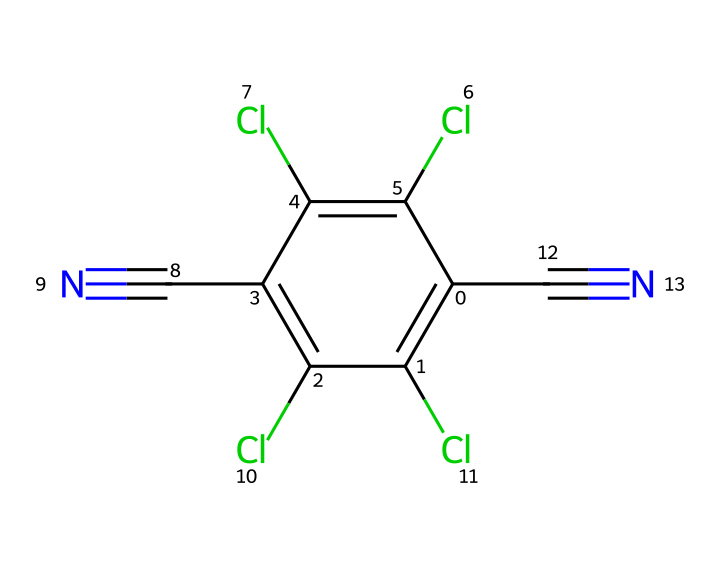What is the molecular formula of chlorothalonil? To find the molecular formula, count the number of each type of atom present in the SMILES representation. The analysis reveals that there are 8 carbon atoms, 4 chlorine atoms, 2 nitrogen atoms, and 4 hydrogen atoms. Therefore, the molecular formula is C8Cl4N2H4.
Answer: C8Cl4N2H4 How many chlorine atoms are in chlorothalonil? By examining the SMILES structure, one can identify that there are 4 chlorine (Cl) atoms marked explicitly. Therefore, the answer is based on direct observation of the structure.
Answer: 4 What functional group is present in chlorothalonil? The chemical structure features a cyano (–C≡N) group, which is an important functional group in many fungicides. The presence of the nitrile indicates the functional group.
Answer: cyano group Is chlorothalonil aromatic? To determine if the compound is aromatic, examine the structure: chlorothalonil contains a cyclic structure with alternating double bonds. This indicates resonance stability and fulfills the criteria for aromaticity.
Answer: yes How many bonds are there in chlorothalonil excluding hydrogen bonds? Counting the connections between atoms in the SMILES representation, one can find that there are 12 significant bonds (double and single combined), which do not include hydrogen bonding considerations.
Answer: 12 